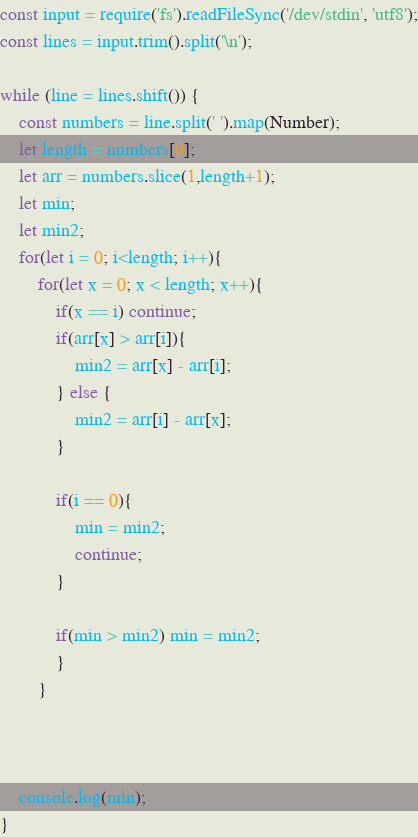Convert code to text. <code><loc_0><loc_0><loc_500><loc_500><_JavaScript_>const input = require('fs').readFileSync('/dev/stdin', 'utf8');
const lines = input.trim().split('\n');

while (line = lines.shift()) {
    const numbers = line.split(' ').map(Number);
    let length = numbers[0];
    let arr = numbers.slice(1,length+1);
    let min; 
    let min2;
    for(let i = 0; i<length; i++){
        for(let x = 0; x < length; x++){
            if(x == i) continue;
            if(arr[x] > arr[i]){
                min2 = arr[x] - arr[i];
            } else {
                min2 = arr[i] - arr[x];
            }
        
            if(i == 0){
                min = min2;
                continue;
            } 
        
            if(min > min2) min = min2;
            }
        }
    


    console.log(min);
}


</code> 